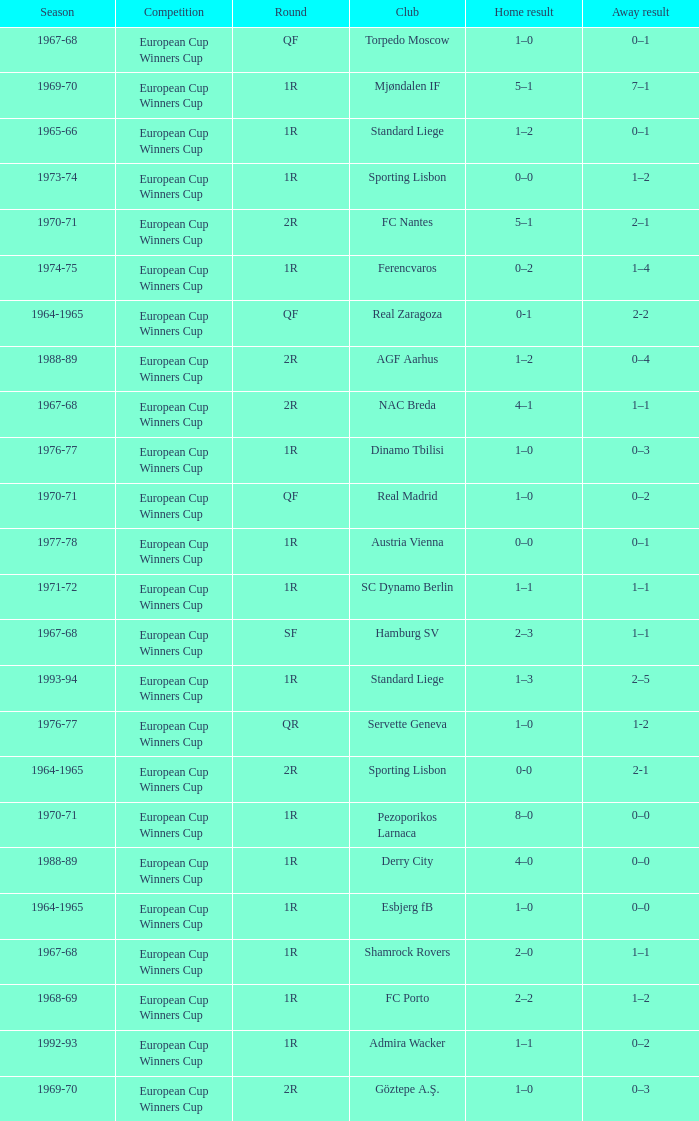Away result of 1–1, and a Round of 1r, and a Season of 1967-68 involves what club? Shamrock Rovers. 